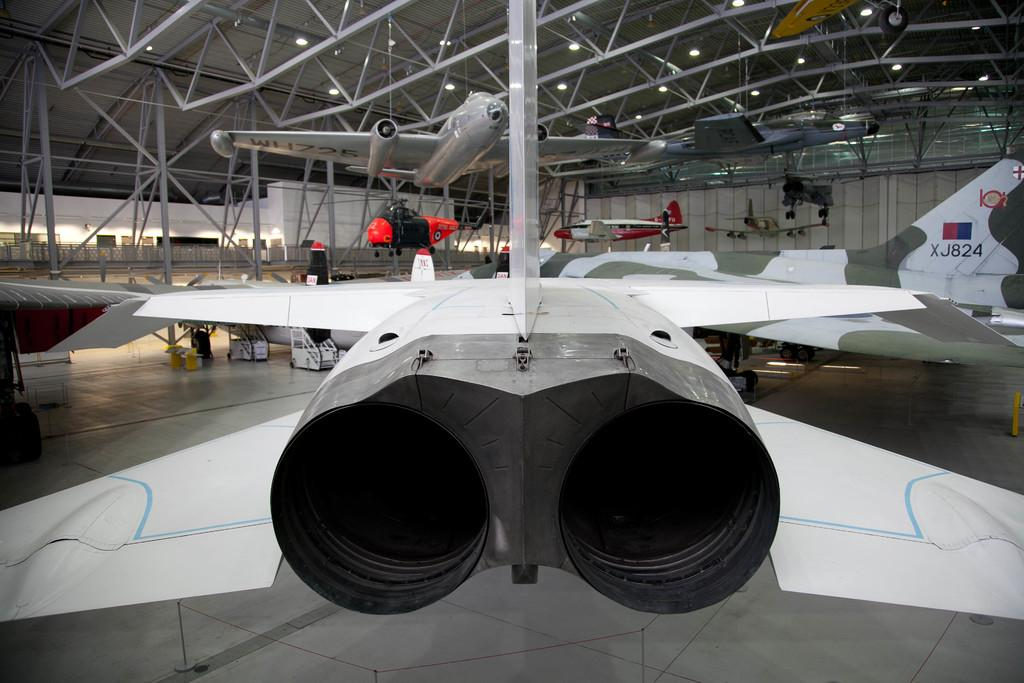<image>
Present a compact description of the photo's key features. The jet on the far right has a serial number that is "XJ824." 